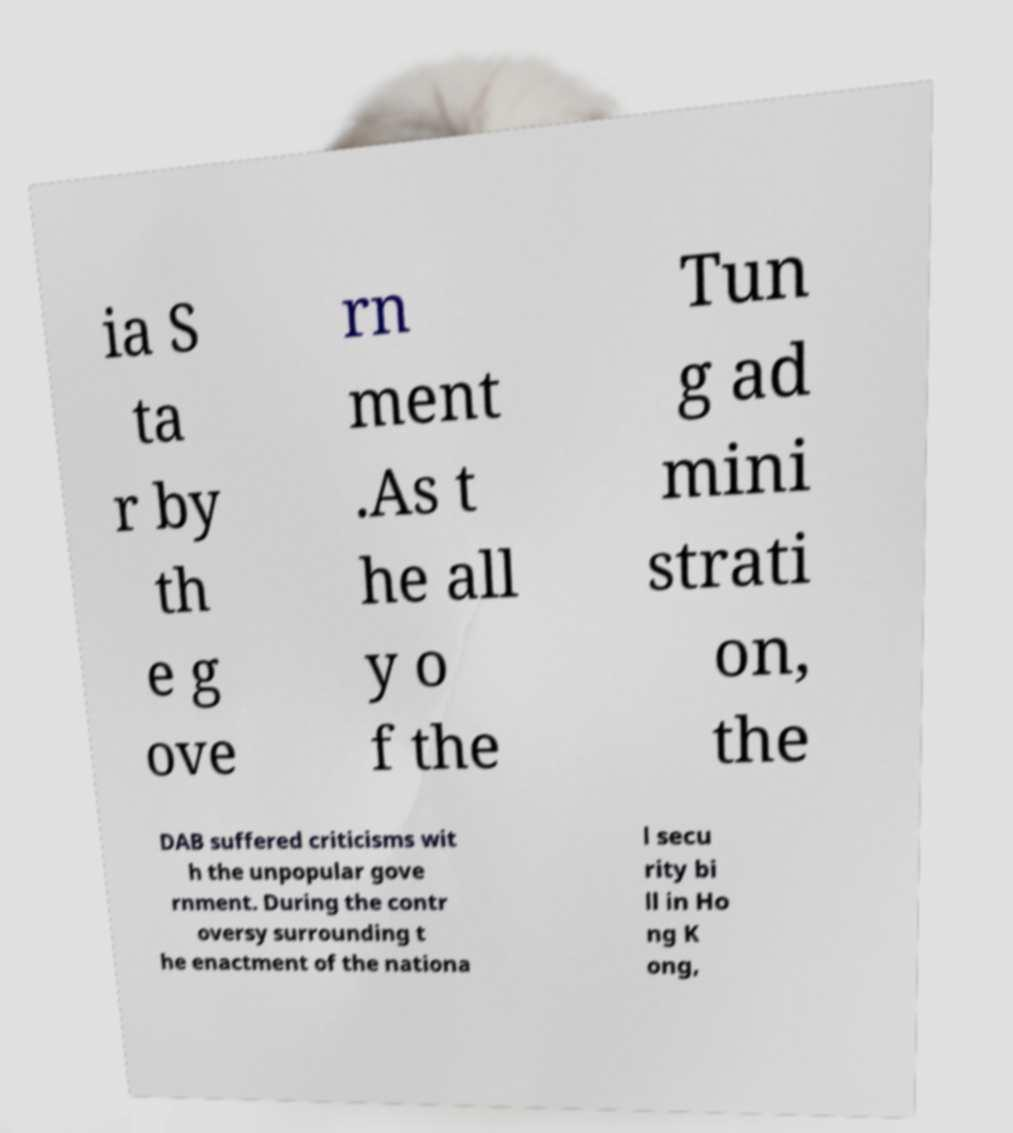Can you read and provide the text displayed in the image?This photo seems to have some interesting text. Can you extract and type it out for me? ia S ta r by th e g ove rn ment .As t he all y o f the Tun g ad mini strati on, the DAB suffered criticisms wit h the unpopular gove rnment. During the contr oversy surrounding t he enactment of the nationa l secu rity bi ll in Ho ng K ong, 